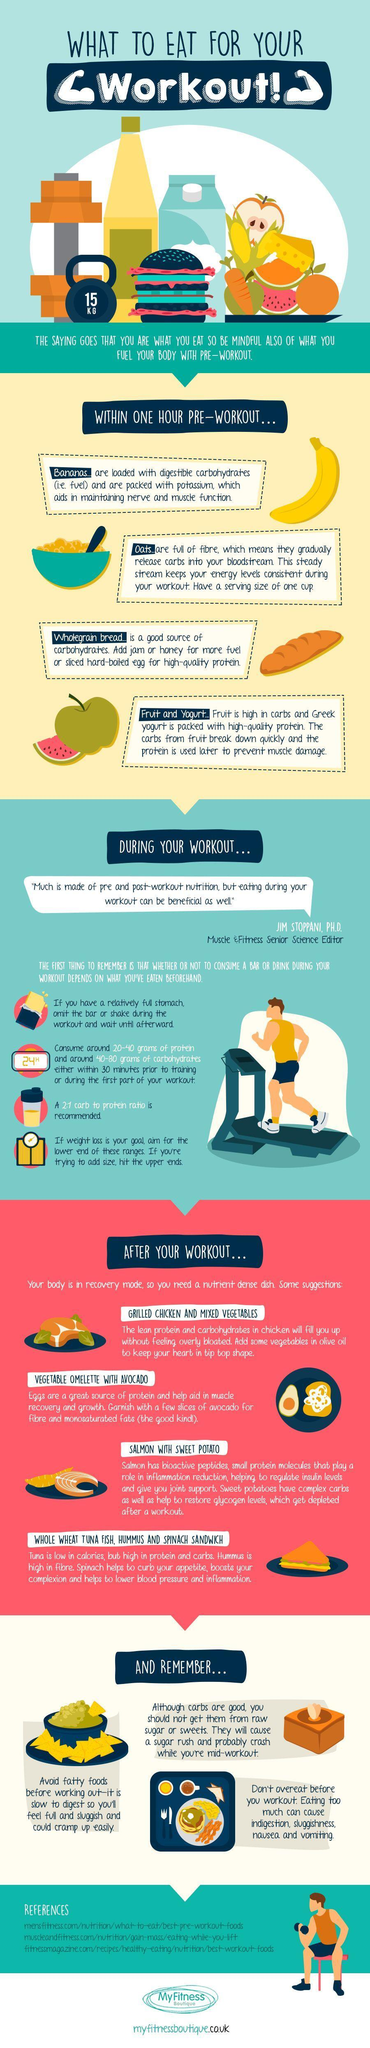How many references are cited?
Answer the question with a short phrase. 3 What is the weight on the kettle bell shown? 15 KG 